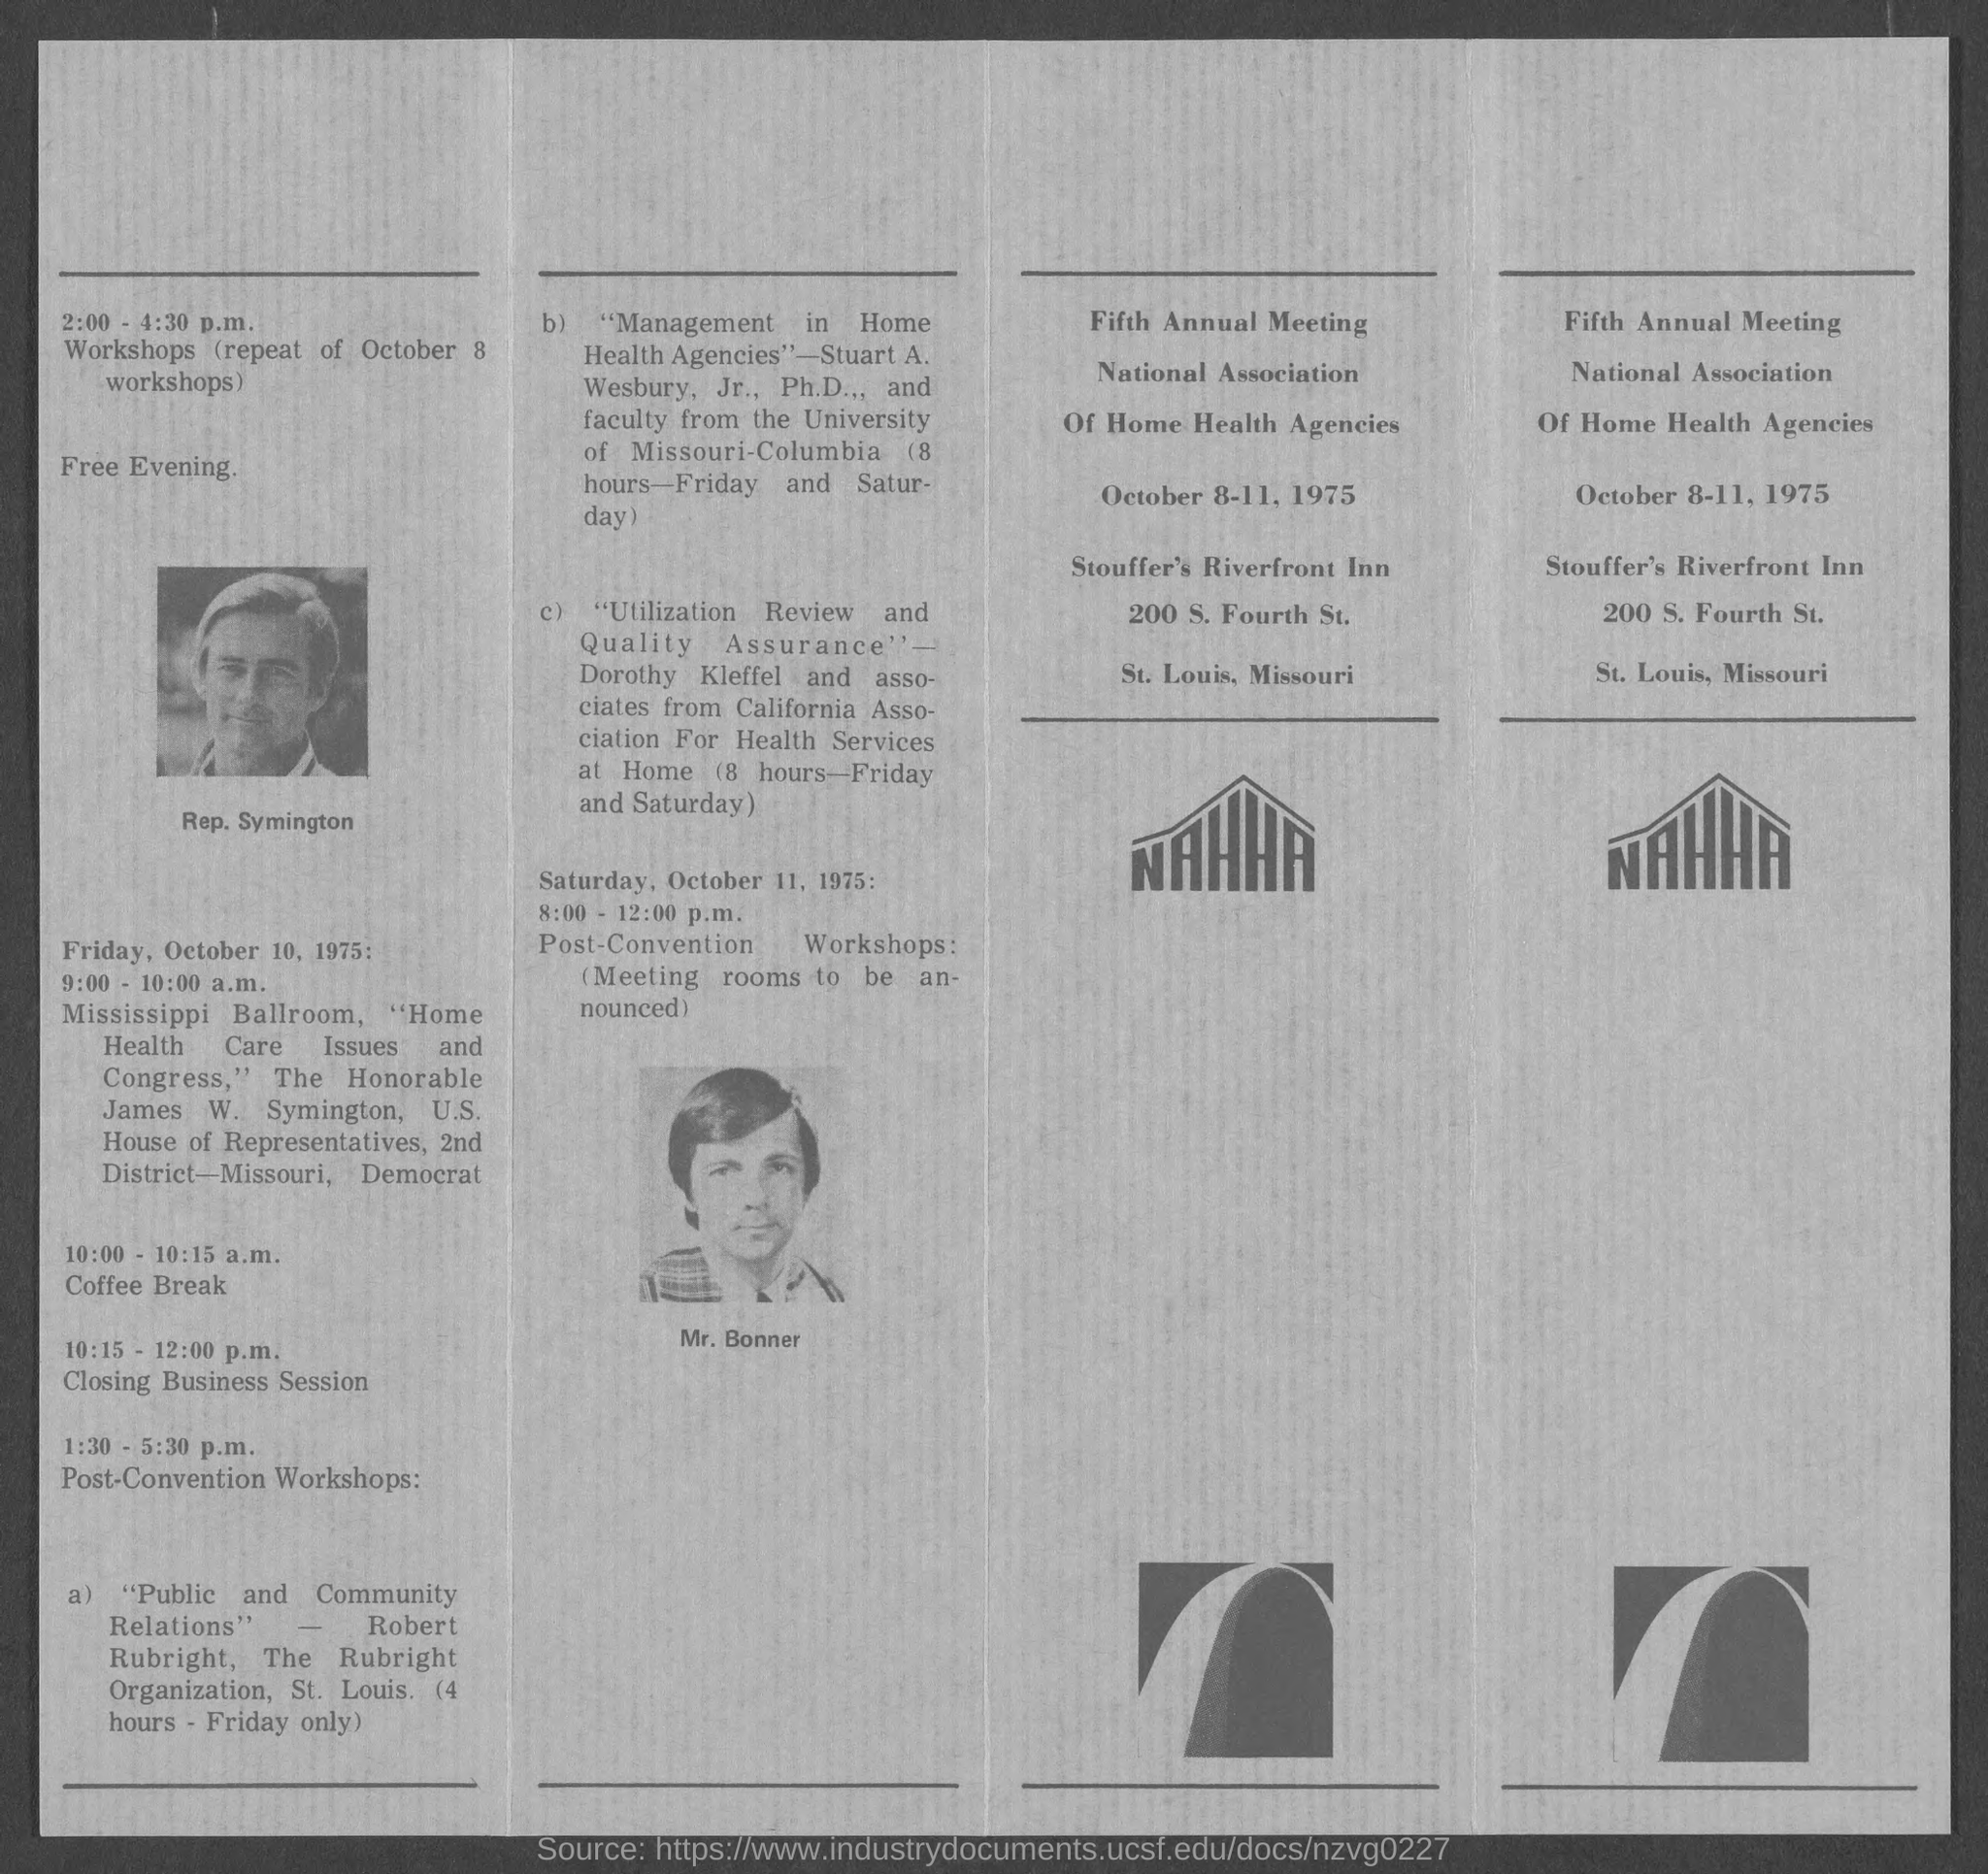Indicate a few pertinent items in this graphic. Stouffer's Riverfront Inn is located in the state of Missouri. 